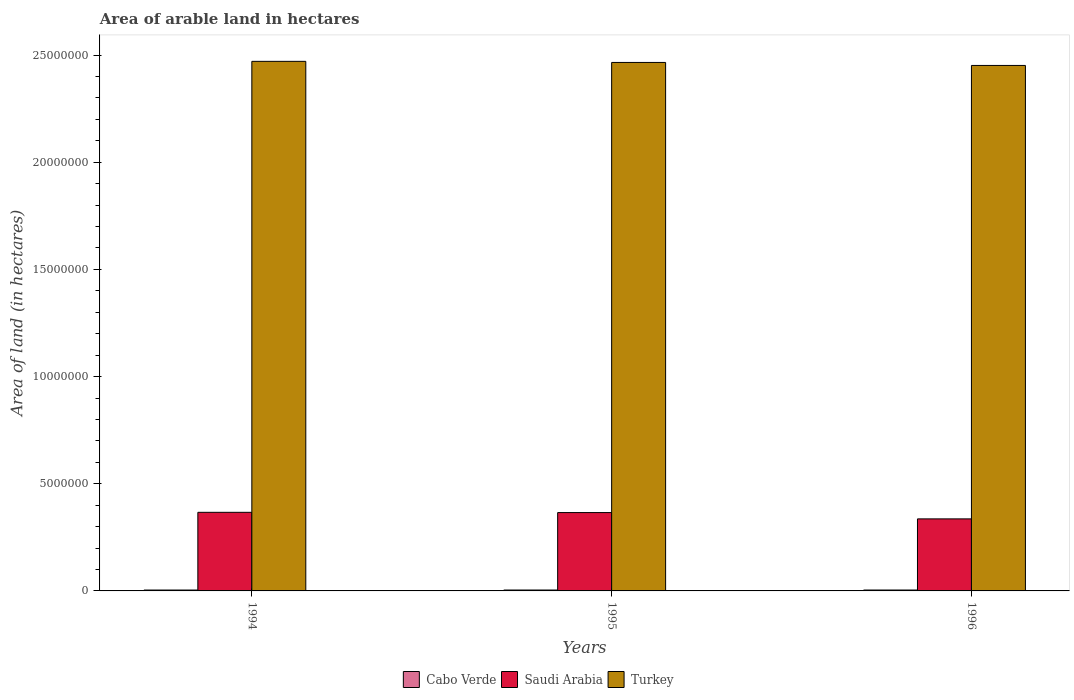How many groups of bars are there?
Make the answer very short. 3. Are the number of bars on each tick of the X-axis equal?
Offer a terse response. Yes. How many bars are there on the 3rd tick from the right?
Your response must be concise. 3. What is the total arable land in Turkey in 1995?
Ensure brevity in your answer.  2.47e+07. Across all years, what is the maximum total arable land in Saudi Arabia?
Make the answer very short. 3.67e+06. Across all years, what is the minimum total arable land in Saudi Arabia?
Ensure brevity in your answer.  3.36e+06. In which year was the total arable land in Cabo Verde minimum?
Ensure brevity in your answer.  1994. What is the total total arable land in Turkey in the graph?
Offer a very short reply. 7.39e+07. What is the difference between the total arable land in Turkey in 1994 and that in 1995?
Offer a very short reply. 5.10e+04. What is the difference between the total arable land in Turkey in 1994 and the total arable land in Saudi Arabia in 1995?
Give a very brief answer. 2.10e+07. What is the average total arable land in Cabo Verde per year?
Give a very brief answer. 4.17e+04. In the year 1996, what is the difference between the total arable land in Saudi Arabia and total arable land in Cabo Verde?
Provide a succinct answer. 3.32e+06. What is the ratio of the total arable land in Saudi Arabia in 1995 to that in 1996?
Your response must be concise. 1.09. Is the total arable land in Cabo Verde in 1994 less than that in 1995?
Your answer should be very brief. Yes. Is the difference between the total arable land in Saudi Arabia in 1995 and 1996 greater than the difference between the total arable land in Cabo Verde in 1995 and 1996?
Keep it short and to the point. Yes. What is the difference between the highest and the second highest total arable land in Cabo Verde?
Keep it short and to the point. 0. What is the difference between the highest and the lowest total arable land in Turkey?
Keep it short and to the point. 1.91e+05. What does the 2nd bar from the right in 1996 represents?
Offer a terse response. Saudi Arabia. Is it the case that in every year, the sum of the total arable land in Saudi Arabia and total arable land in Cabo Verde is greater than the total arable land in Turkey?
Provide a short and direct response. No. How many years are there in the graph?
Make the answer very short. 3. Are the values on the major ticks of Y-axis written in scientific E-notation?
Ensure brevity in your answer.  No. What is the title of the graph?
Your response must be concise. Area of arable land in hectares. Does "Hungary" appear as one of the legend labels in the graph?
Offer a very short reply. No. What is the label or title of the X-axis?
Keep it short and to the point. Years. What is the label or title of the Y-axis?
Offer a very short reply. Area of land (in hectares). What is the Area of land (in hectares) in Cabo Verde in 1994?
Offer a terse response. 4.10e+04. What is the Area of land (in hectares) in Saudi Arabia in 1994?
Offer a terse response. 3.67e+06. What is the Area of land (in hectares) of Turkey in 1994?
Offer a very short reply. 2.47e+07. What is the Area of land (in hectares) in Cabo Verde in 1995?
Offer a terse response. 4.20e+04. What is the Area of land (in hectares) in Saudi Arabia in 1995?
Your response must be concise. 3.66e+06. What is the Area of land (in hectares) in Turkey in 1995?
Your response must be concise. 2.47e+07. What is the Area of land (in hectares) of Cabo Verde in 1996?
Keep it short and to the point. 4.20e+04. What is the Area of land (in hectares) of Saudi Arabia in 1996?
Offer a terse response. 3.36e+06. What is the Area of land (in hectares) in Turkey in 1996?
Your answer should be compact. 2.45e+07. Across all years, what is the maximum Area of land (in hectares) of Cabo Verde?
Give a very brief answer. 4.20e+04. Across all years, what is the maximum Area of land (in hectares) in Saudi Arabia?
Offer a terse response. 3.67e+06. Across all years, what is the maximum Area of land (in hectares) of Turkey?
Ensure brevity in your answer.  2.47e+07. Across all years, what is the minimum Area of land (in hectares) in Cabo Verde?
Provide a short and direct response. 4.10e+04. Across all years, what is the minimum Area of land (in hectares) in Saudi Arabia?
Give a very brief answer. 3.36e+06. Across all years, what is the minimum Area of land (in hectares) in Turkey?
Your response must be concise. 2.45e+07. What is the total Area of land (in hectares) of Cabo Verde in the graph?
Your answer should be very brief. 1.25e+05. What is the total Area of land (in hectares) of Saudi Arabia in the graph?
Your response must be concise. 1.07e+07. What is the total Area of land (in hectares) in Turkey in the graph?
Your answer should be compact. 7.39e+07. What is the difference between the Area of land (in hectares) of Cabo Verde in 1994 and that in 1995?
Make the answer very short. -1000. What is the difference between the Area of land (in hectares) of Saudi Arabia in 1994 and that in 1995?
Offer a very short reply. 1.20e+04. What is the difference between the Area of land (in hectares) of Turkey in 1994 and that in 1995?
Provide a succinct answer. 5.10e+04. What is the difference between the Area of land (in hectares) in Cabo Verde in 1994 and that in 1996?
Offer a terse response. -1000. What is the difference between the Area of land (in hectares) of Saudi Arabia in 1994 and that in 1996?
Your answer should be very brief. 3.06e+05. What is the difference between the Area of land (in hectares) in Turkey in 1994 and that in 1996?
Offer a terse response. 1.91e+05. What is the difference between the Area of land (in hectares) of Saudi Arabia in 1995 and that in 1996?
Your answer should be compact. 2.94e+05. What is the difference between the Area of land (in hectares) of Cabo Verde in 1994 and the Area of land (in hectares) of Saudi Arabia in 1995?
Ensure brevity in your answer.  -3.61e+06. What is the difference between the Area of land (in hectares) of Cabo Verde in 1994 and the Area of land (in hectares) of Turkey in 1995?
Provide a short and direct response. -2.46e+07. What is the difference between the Area of land (in hectares) in Saudi Arabia in 1994 and the Area of land (in hectares) in Turkey in 1995?
Your answer should be compact. -2.10e+07. What is the difference between the Area of land (in hectares) of Cabo Verde in 1994 and the Area of land (in hectares) of Saudi Arabia in 1996?
Give a very brief answer. -3.32e+06. What is the difference between the Area of land (in hectares) in Cabo Verde in 1994 and the Area of land (in hectares) in Turkey in 1996?
Offer a terse response. -2.45e+07. What is the difference between the Area of land (in hectares) in Saudi Arabia in 1994 and the Area of land (in hectares) in Turkey in 1996?
Give a very brief answer. -2.08e+07. What is the difference between the Area of land (in hectares) in Cabo Verde in 1995 and the Area of land (in hectares) in Saudi Arabia in 1996?
Offer a terse response. -3.32e+06. What is the difference between the Area of land (in hectares) of Cabo Verde in 1995 and the Area of land (in hectares) of Turkey in 1996?
Ensure brevity in your answer.  -2.45e+07. What is the difference between the Area of land (in hectares) in Saudi Arabia in 1995 and the Area of land (in hectares) in Turkey in 1996?
Provide a short and direct response. -2.09e+07. What is the average Area of land (in hectares) of Cabo Verde per year?
Your answer should be very brief. 4.17e+04. What is the average Area of land (in hectares) in Saudi Arabia per year?
Your answer should be compact. 3.56e+06. What is the average Area of land (in hectares) of Turkey per year?
Your response must be concise. 2.46e+07. In the year 1994, what is the difference between the Area of land (in hectares) in Cabo Verde and Area of land (in hectares) in Saudi Arabia?
Ensure brevity in your answer.  -3.63e+06. In the year 1994, what is the difference between the Area of land (in hectares) of Cabo Verde and Area of land (in hectares) of Turkey?
Offer a terse response. -2.47e+07. In the year 1994, what is the difference between the Area of land (in hectares) in Saudi Arabia and Area of land (in hectares) in Turkey?
Offer a very short reply. -2.10e+07. In the year 1995, what is the difference between the Area of land (in hectares) of Cabo Verde and Area of land (in hectares) of Saudi Arabia?
Provide a succinct answer. -3.61e+06. In the year 1995, what is the difference between the Area of land (in hectares) of Cabo Verde and Area of land (in hectares) of Turkey?
Your answer should be compact. -2.46e+07. In the year 1995, what is the difference between the Area of land (in hectares) of Saudi Arabia and Area of land (in hectares) of Turkey?
Your answer should be very brief. -2.10e+07. In the year 1996, what is the difference between the Area of land (in hectares) of Cabo Verde and Area of land (in hectares) of Saudi Arabia?
Provide a short and direct response. -3.32e+06. In the year 1996, what is the difference between the Area of land (in hectares) of Cabo Verde and Area of land (in hectares) of Turkey?
Make the answer very short. -2.45e+07. In the year 1996, what is the difference between the Area of land (in hectares) of Saudi Arabia and Area of land (in hectares) of Turkey?
Your answer should be compact. -2.12e+07. What is the ratio of the Area of land (in hectares) in Cabo Verde in 1994 to that in 1995?
Your answer should be compact. 0.98. What is the ratio of the Area of land (in hectares) in Saudi Arabia in 1994 to that in 1995?
Offer a very short reply. 1. What is the ratio of the Area of land (in hectares) of Turkey in 1994 to that in 1995?
Give a very brief answer. 1. What is the ratio of the Area of land (in hectares) in Cabo Verde in 1994 to that in 1996?
Your response must be concise. 0.98. What is the ratio of the Area of land (in hectares) in Saudi Arabia in 1994 to that in 1996?
Your response must be concise. 1.09. What is the ratio of the Area of land (in hectares) of Cabo Verde in 1995 to that in 1996?
Give a very brief answer. 1. What is the ratio of the Area of land (in hectares) in Saudi Arabia in 1995 to that in 1996?
Keep it short and to the point. 1.09. What is the ratio of the Area of land (in hectares) of Turkey in 1995 to that in 1996?
Make the answer very short. 1.01. What is the difference between the highest and the second highest Area of land (in hectares) in Cabo Verde?
Provide a succinct answer. 0. What is the difference between the highest and the second highest Area of land (in hectares) in Saudi Arabia?
Make the answer very short. 1.20e+04. What is the difference between the highest and the second highest Area of land (in hectares) of Turkey?
Ensure brevity in your answer.  5.10e+04. What is the difference between the highest and the lowest Area of land (in hectares) in Cabo Verde?
Give a very brief answer. 1000. What is the difference between the highest and the lowest Area of land (in hectares) of Saudi Arabia?
Make the answer very short. 3.06e+05. What is the difference between the highest and the lowest Area of land (in hectares) in Turkey?
Offer a terse response. 1.91e+05. 